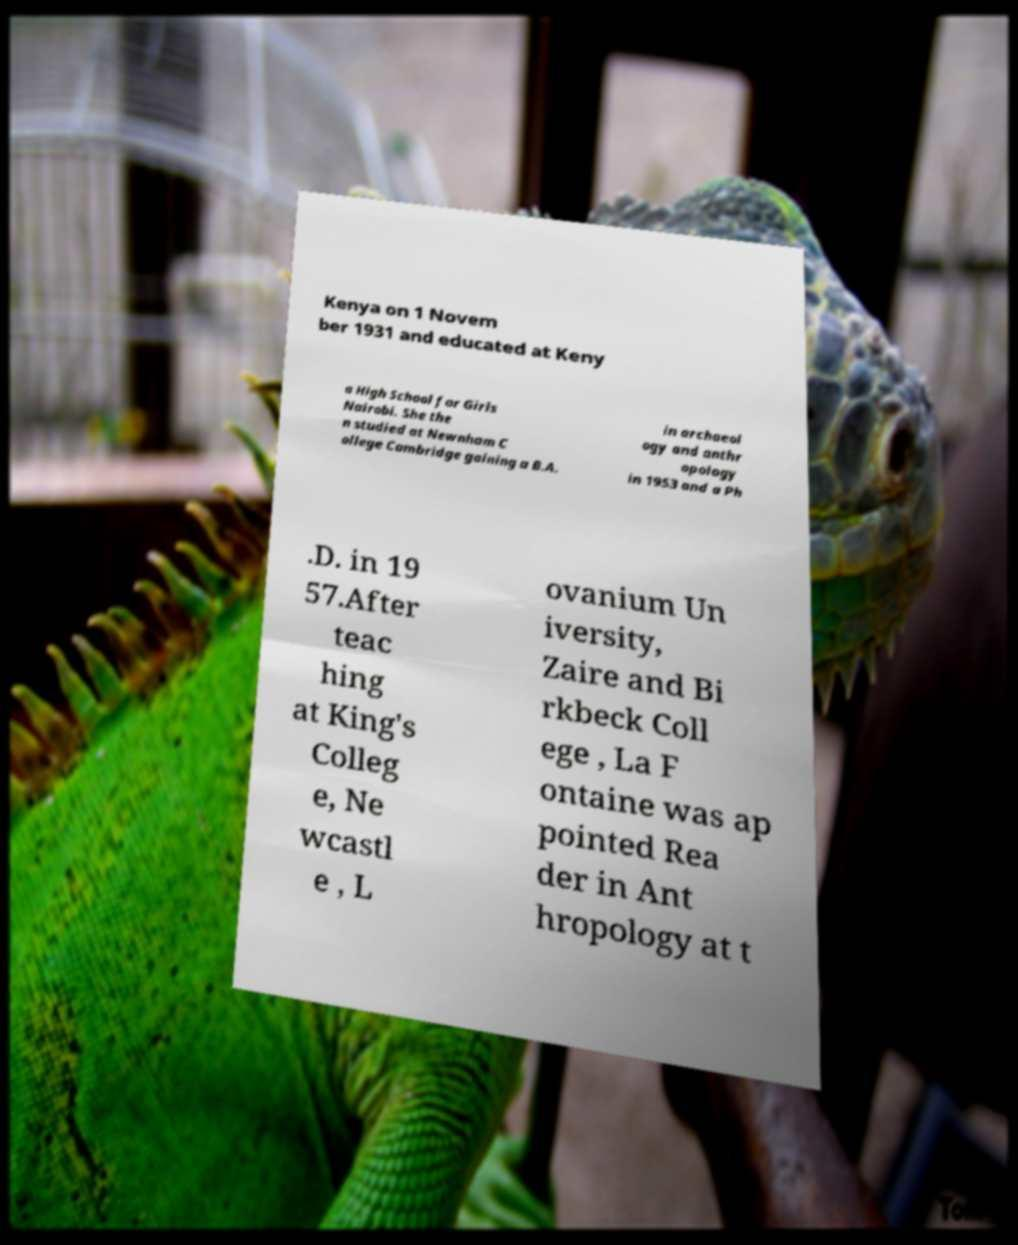For documentation purposes, I need the text within this image transcribed. Could you provide that? Kenya on 1 Novem ber 1931 and educated at Keny a High School for Girls Nairobi. She the n studied at Newnham C ollege Cambridge gaining a B.A. in archaeol ogy and anthr opology in 1953 and a Ph .D. in 19 57.After teac hing at King's Colleg e, Ne wcastl e , L ovanium Un iversity, Zaire and Bi rkbeck Coll ege , La F ontaine was ap pointed Rea der in Ant hropology at t 